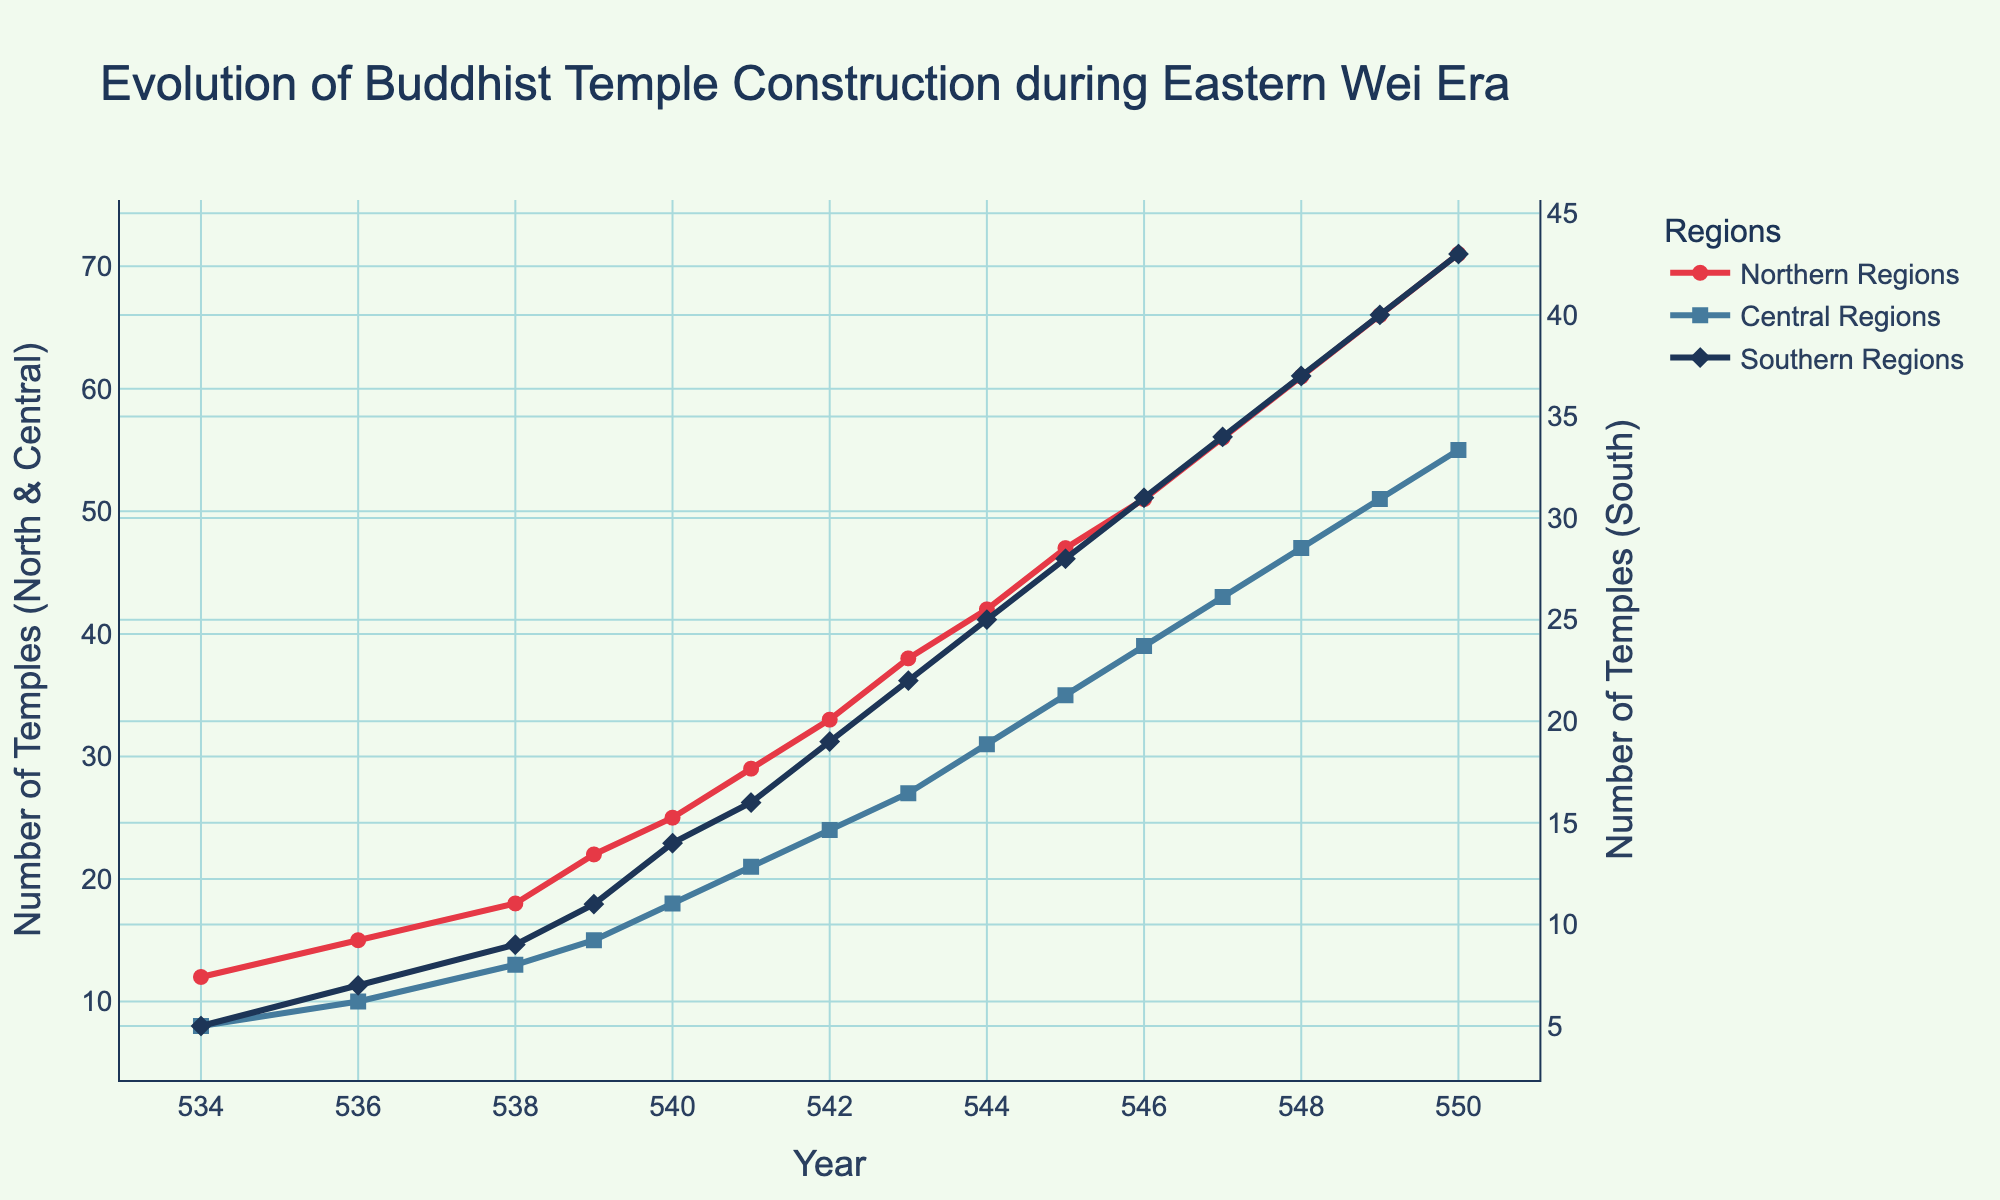What year had the highest number of Buddhist temples constructed in the Northern Regions? The highest number of Buddhist temples constructed in the Northern Regions, as visually seen in the figure, occurred in the year 550.
Answer: 550 Between which years did the Central Regions see the greatest increase in the number of Buddhist temples constructed? By visually analyzing the plot, the slopes of the lines can be observed. The Central Regions saw the greatest increase between 544 and 545, where the number of temples increased from 31 to 35, totaling a difference of 4.
Answer: 544-545 How many total temples were constructed across all regions in 545? Add the number of temples for each region in 545 from the figure: Northern (47) + Central (35) + Southern (28) = 110.
Answer: 110 Which region had the least number of temples constructed in 539? Visually comparing the values in the figure for the year 539, the Southern Regions had the least number of temples constructed, with 11 temples.
Answer: Southern Regions Between 534 and 550, what is the average number of temples constructed per year in the Northern Regions? Sum the number of temples in the Northern Regions for all the years and divide by the number of years (15). (12+15+18+22+25+29+33+38+42+47+51+56+61+66+71) = 580. Average = 580 / 15 = 38.67.
Answer: 38.67 What is the total increase in the number of Buddhist temples constructed in the Southern Regions from 534 to 550? Subtract the number of temples in 534 from the number in 550 in the Southern Regions: 43 (in 550) - 5 (in 534) = 38.
Answer: 38 How does the number of temples constructed in the Central Regions in 542 compare to that in the Southern Regions in the same year? From the figure, in 542, the Central Regions had 24 temples, while the Southern Regions had 19 temples. Hence, the Central Regions had more temples than the Southern Regions.
Answer: Central Regions had more What was the increase in the number of temples constructed in the Northern and Southern Regions from 543 to 544? Increase in Northern Regions from 543 to 544: 42 - 38 = 4. Increase in Southern Regions from 543 to 544: 25 - 22 = 3. Total increase: 4 + 3 = 7.
Answer: 7 